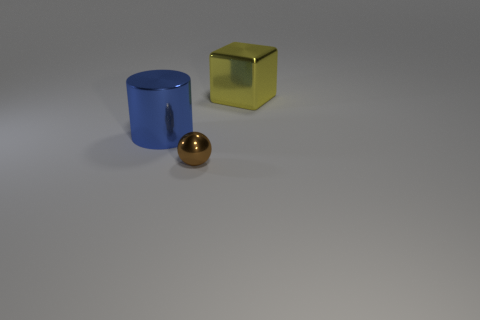Is there any other thing that has the same material as the small brown object?
Your answer should be very brief. Yes. Is there anything else that is the same shape as the tiny brown object?
Your answer should be very brief. No. Is there any other thing that has the same size as the brown metallic thing?
Offer a terse response. No. What is the shape of the metal thing that is both in front of the yellow shiny object and on the right side of the blue thing?
Offer a very short reply. Sphere. What is the shape of the object behind the large object that is in front of the large yellow block that is behind the tiny metallic thing?
Provide a succinct answer. Cube. Is the number of yellow shiny cubes less than the number of big red spheres?
Keep it short and to the point. No. What material is the object that is the same size as the blue shiny cylinder?
Your response must be concise. Metal. There is a thing in front of the blue object; is it the same size as the metallic cylinder?
Your response must be concise. No. Is the number of big yellow metallic things greater than the number of cyan blocks?
Offer a terse response. Yes. How many tiny objects are blue things or blue metal spheres?
Offer a terse response. 0. 